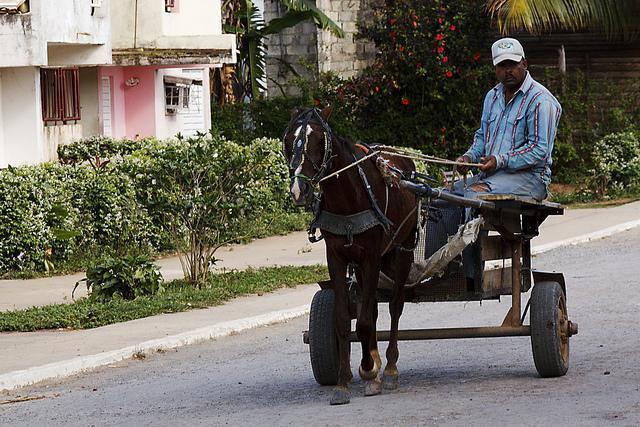How many horses can you see?
Give a very brief answer. 1. How many cats are sitting on the floor?
Give a very brief answer. 0. 